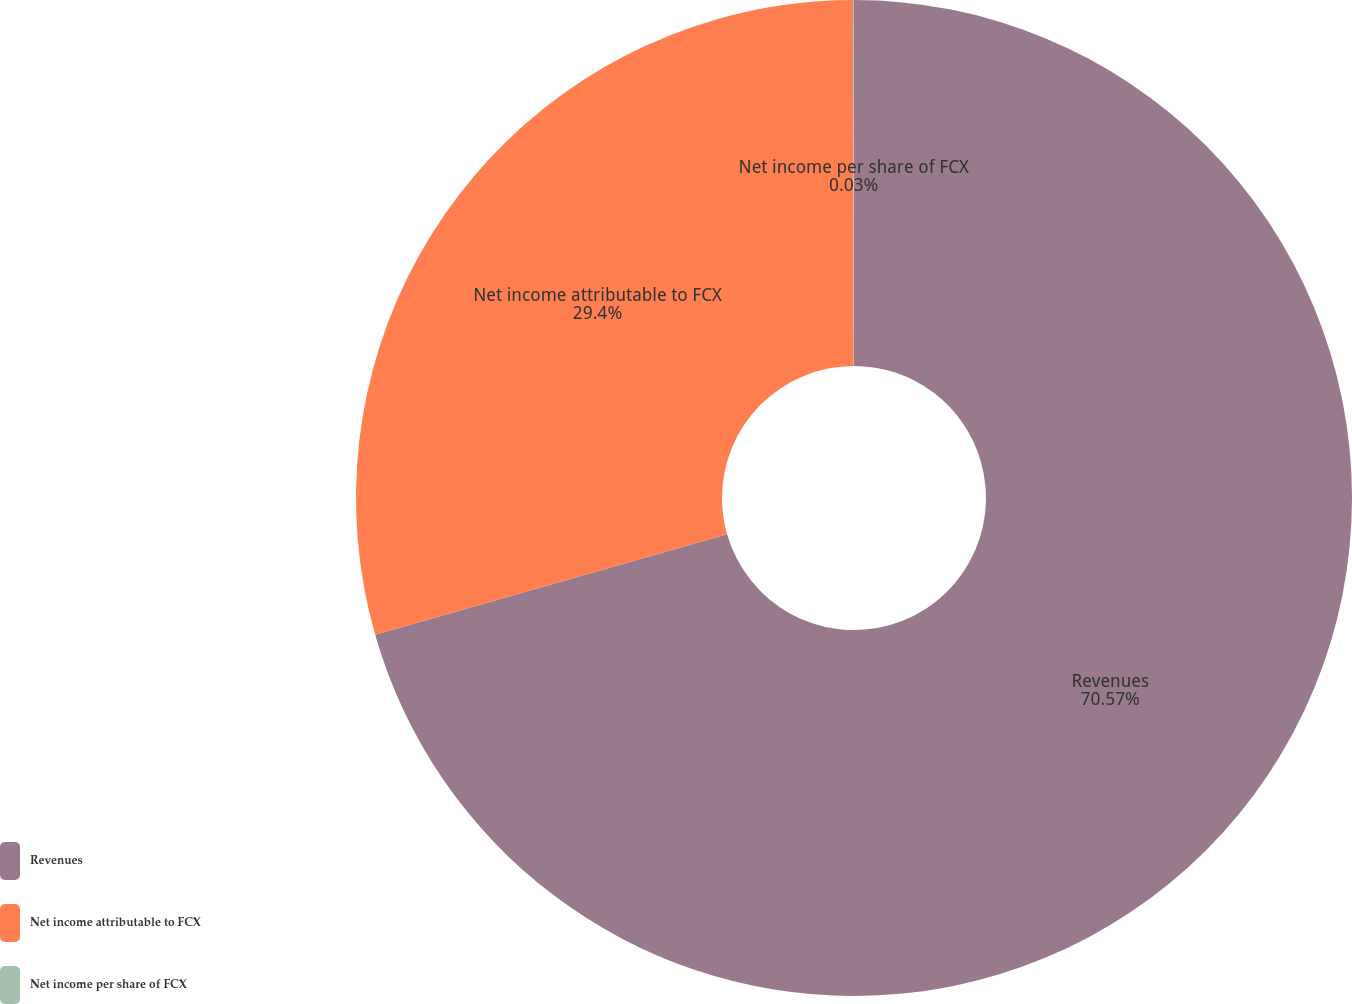Convert chart to OTSL. <chart><loc_0><loc_0><loc_500><loc_500><pie_chart><fcel>Revenues<fcel>Net income attributable to FCX<fcel>Net income per share of FCX<nl><fcel>70.57%<fcel>29.4%<fcel>0.03%<nl></chart> 